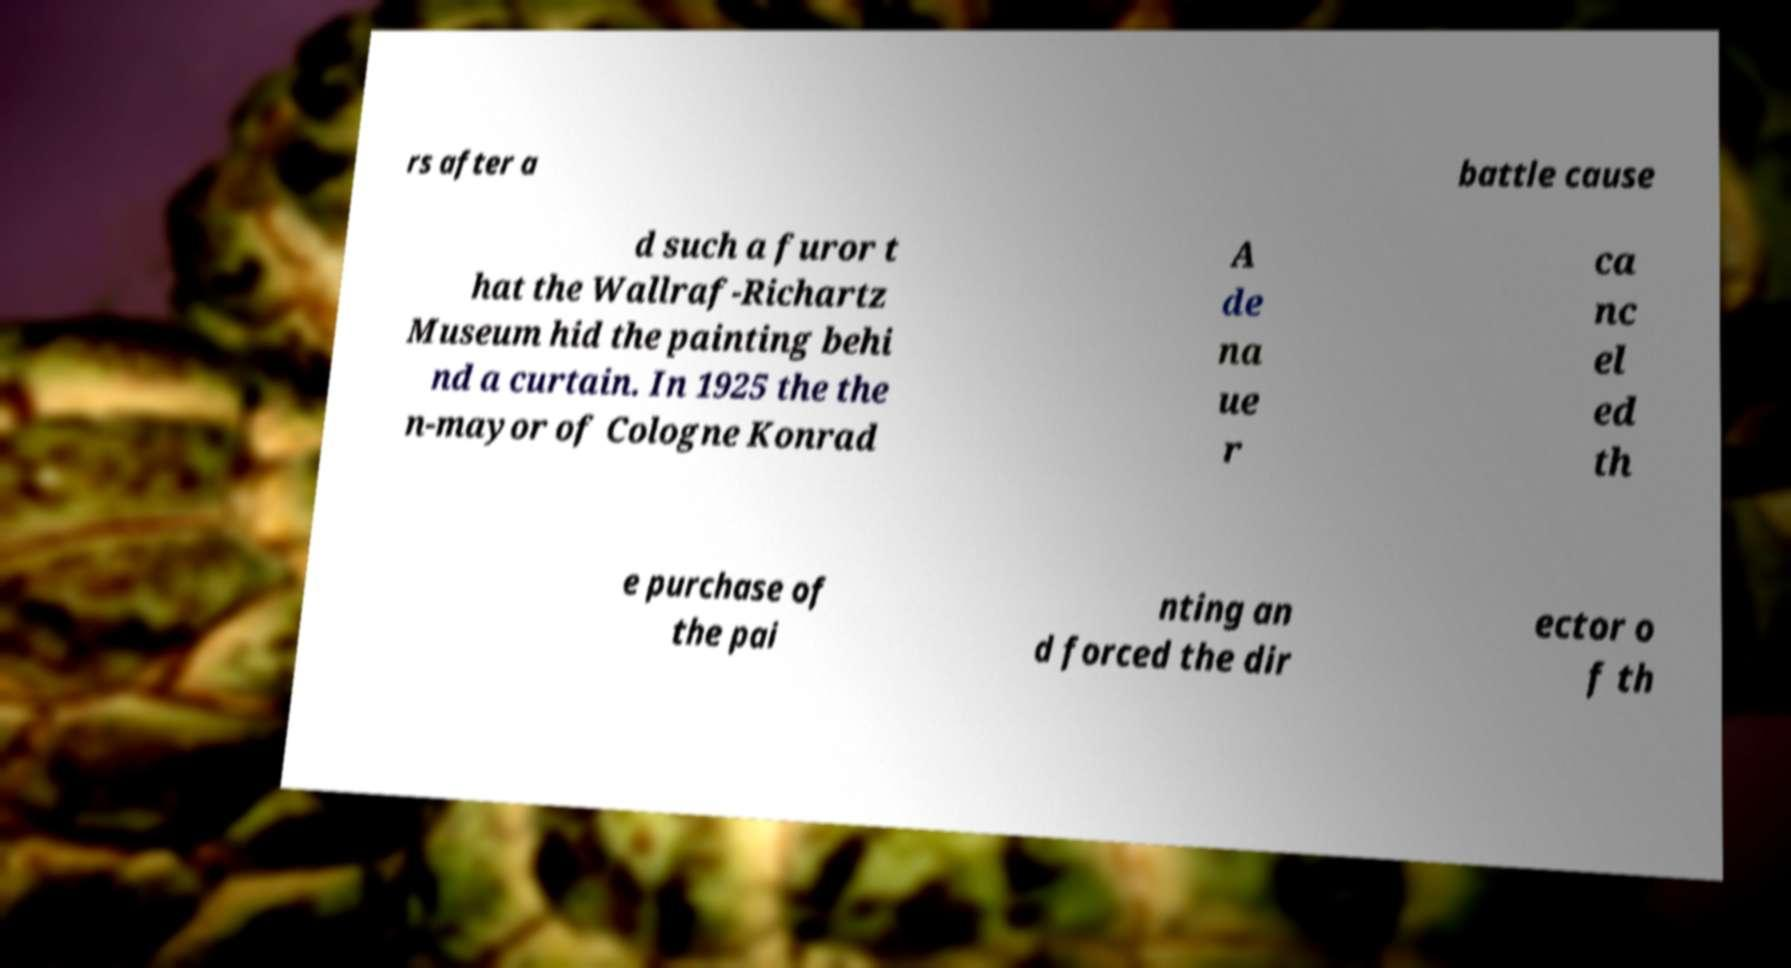Please identify and transcribe the text found in this image. rs after a battle cause d such a furor t hat the Wallraf-Richartz Museum hid the painting behi nd a curtain. In 1925 the the n-mayor of Cologne Konrad A de na ue r ca nc el ed th e purchase of the pai nting an d forced the dir ector o f th 